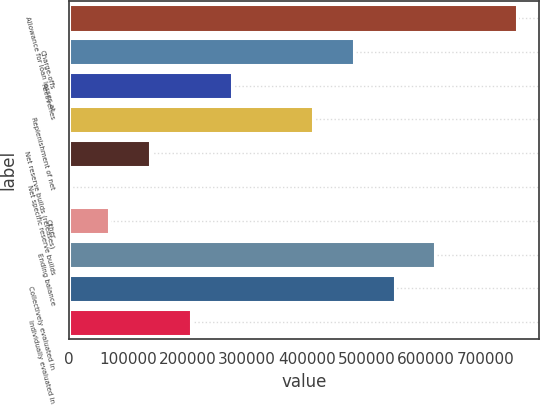<chart> <loc_0><loc_0><loc_500><loc_500><bar_chart><fcel>Allowance for loan losses at<fcel>Charge-offs<fcel>Recoveries<fcel>Replenishment of net<fcel>Net reserve builds (releases)<fcel>Net specific reserve builds<fcel>Other<fcel>Ending balance<fcel>Collectively evaluated in<fcel>Individually evaluated in<nl><fcel>752600<fcel>478983<fcel>273770<fcel>410579<fcel>136962<fcel>153<fcel>68557.3<fcel>615792<fcel>547387<fcel>205366<nl></chart> 